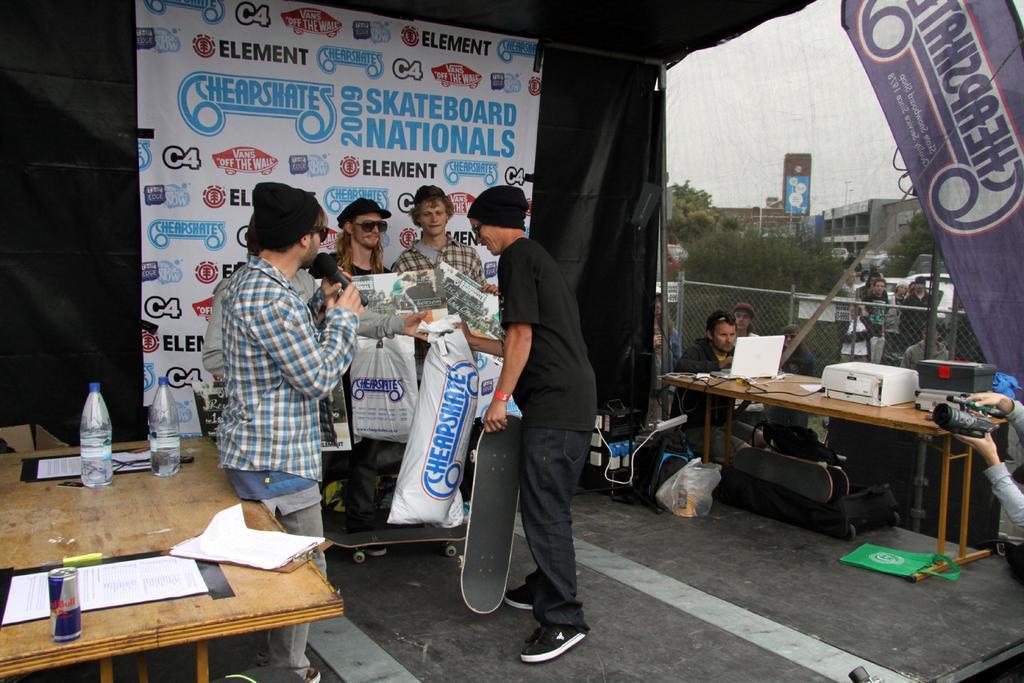In one or two sentences, can you explain what this image depicts? In this image there are five persons standing on a stage. The person in the black t shirt, black jeans, black shoes is holding a board. A person in a check shirt and blue jeans is holding a mike and other three are holding covers. In the left side there is a table, on the table are bottles, pads, papers and a can. In the right side there is another table, a device, a computer, wires placed on it, under the table there is a bag. To the right corner there is another person holding a camera. In the background there is a board and some text printed on it. In the top right there are some buildings, trees , people and trucks etc. 